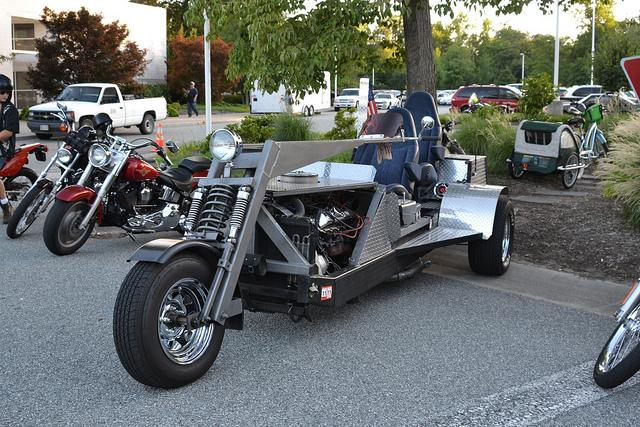How many cylinders does the engine in this custom tricycle have? Please explain your reasoning. eight. The tricycle has 8 cylinders in total. 